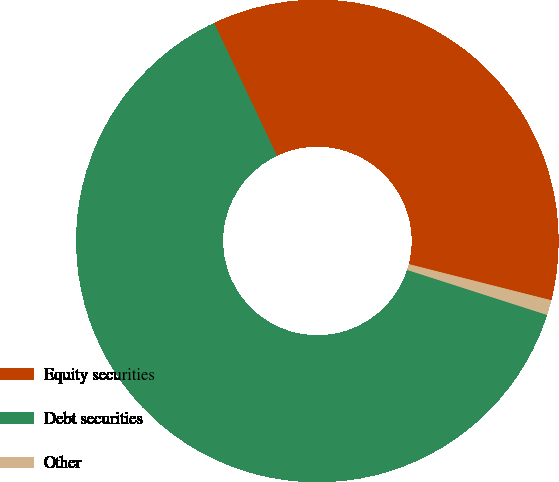<chart> <loc_0><loc_0><loc_500><loc_500><pie_chart><fcel>Equity securities<fcel>Debt securities<fcel>Other<nl><fcel>36.0%<fcel>63.0%<fcel>1.0%<nl></chart> 